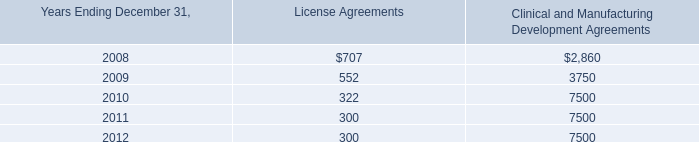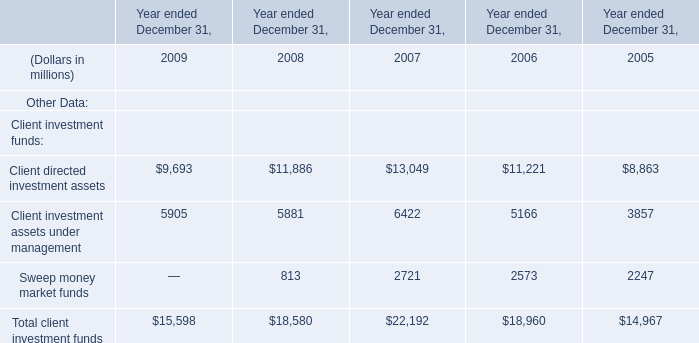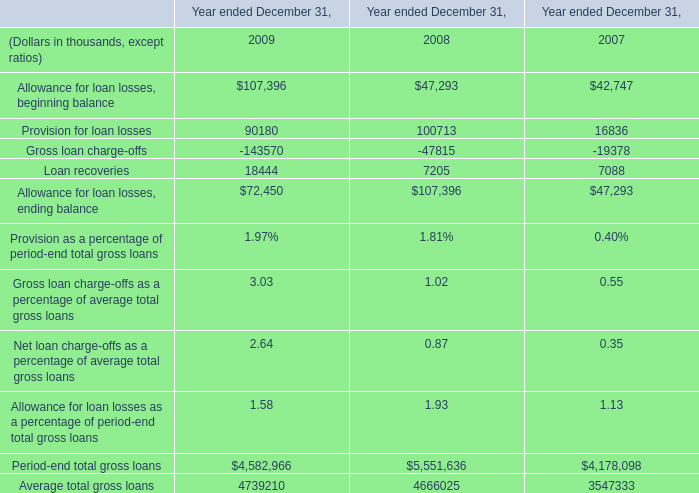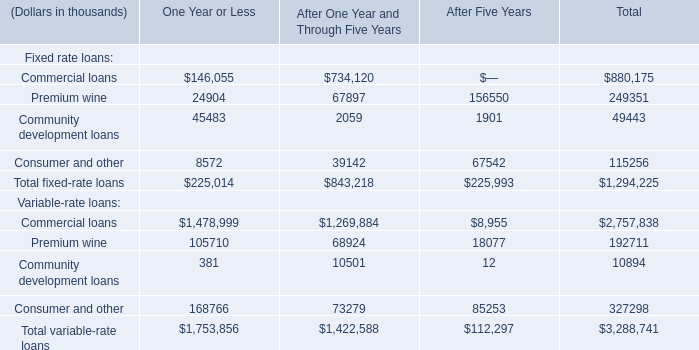What's the average of Client directed investment assets of Year ended December 31, 2009, and Provision for loan losses of Year ended December 31, 2007 ? 
Computations: ((9693.0 + 16836.0) / 2)
Answer: 13264.5. 